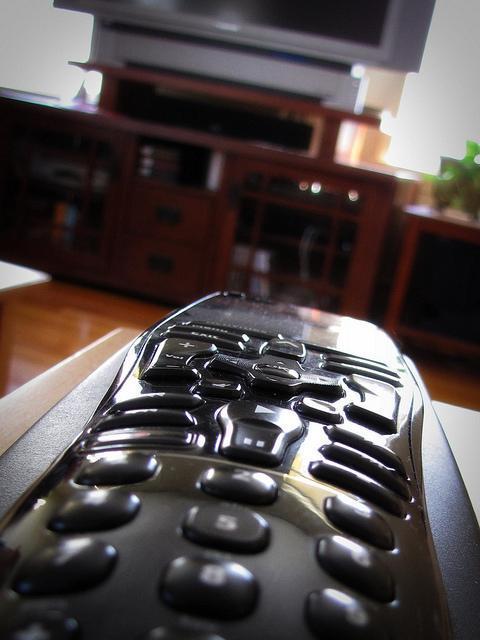How many people are not wearing shirts?
Give a very brief answer. 0. 